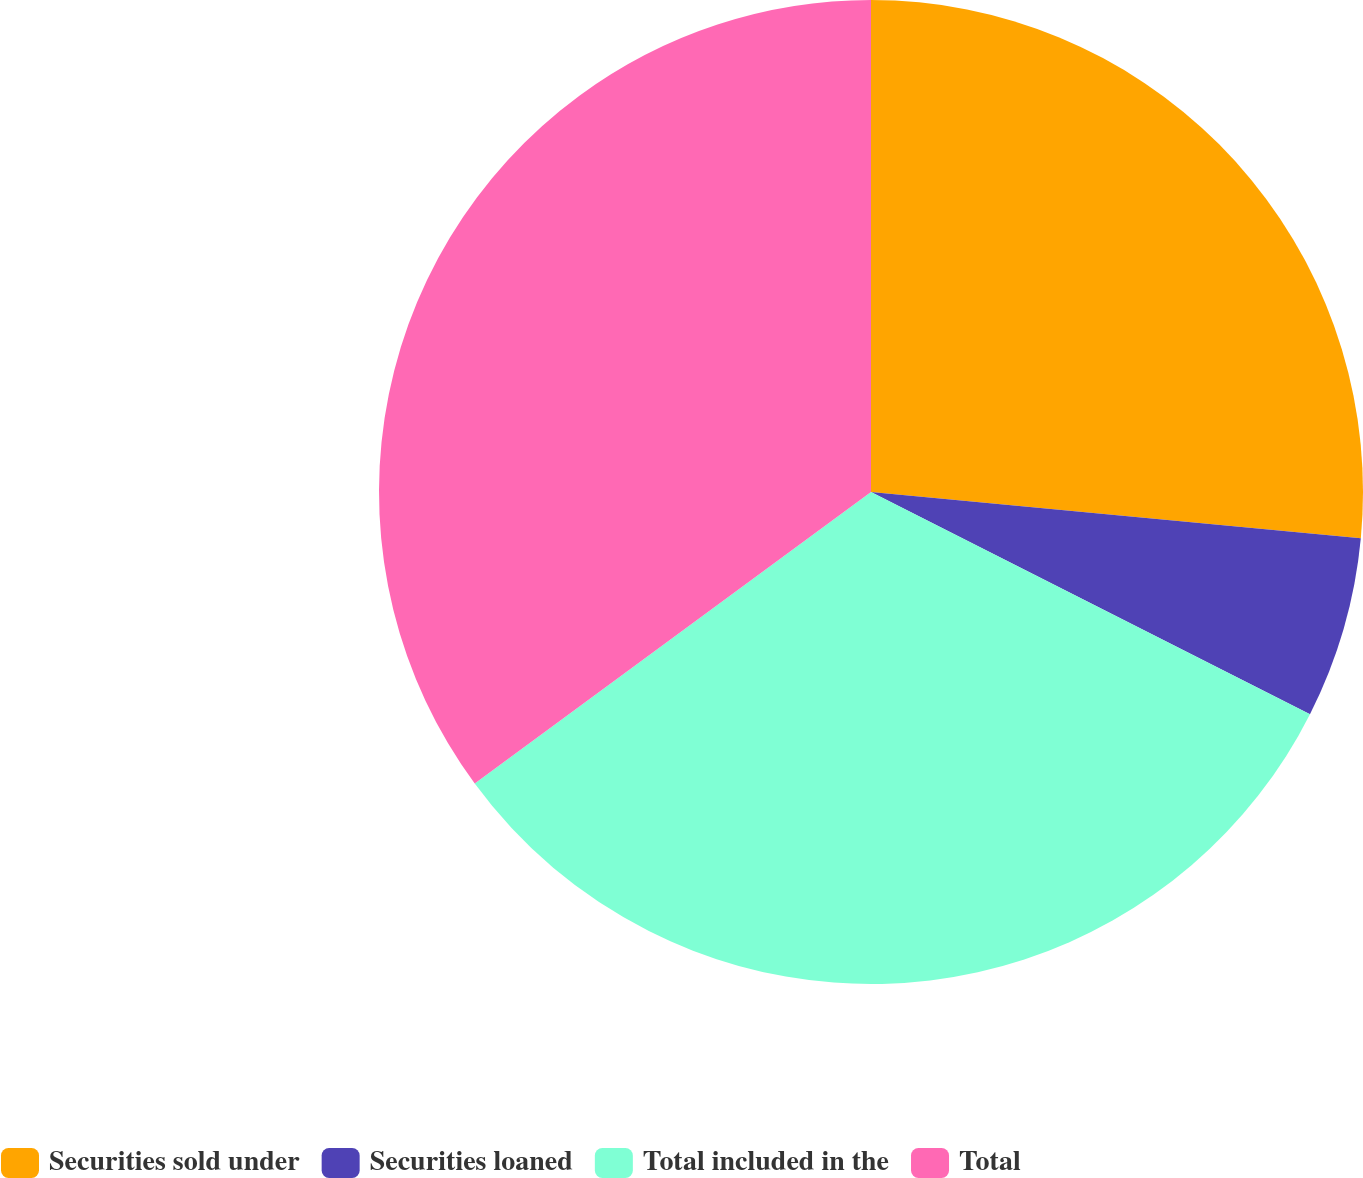<chart> <loc_0><loc_0><loc_500><loc_500><pie_chart><fcel>Securities sold under<fcel>Securities loaned<fcel>Total included in the<fcel>Total<nl><fcel>26.5%<fcel>5.96%<fcel>32.45%<fcel>35.1%<nl></chart> 